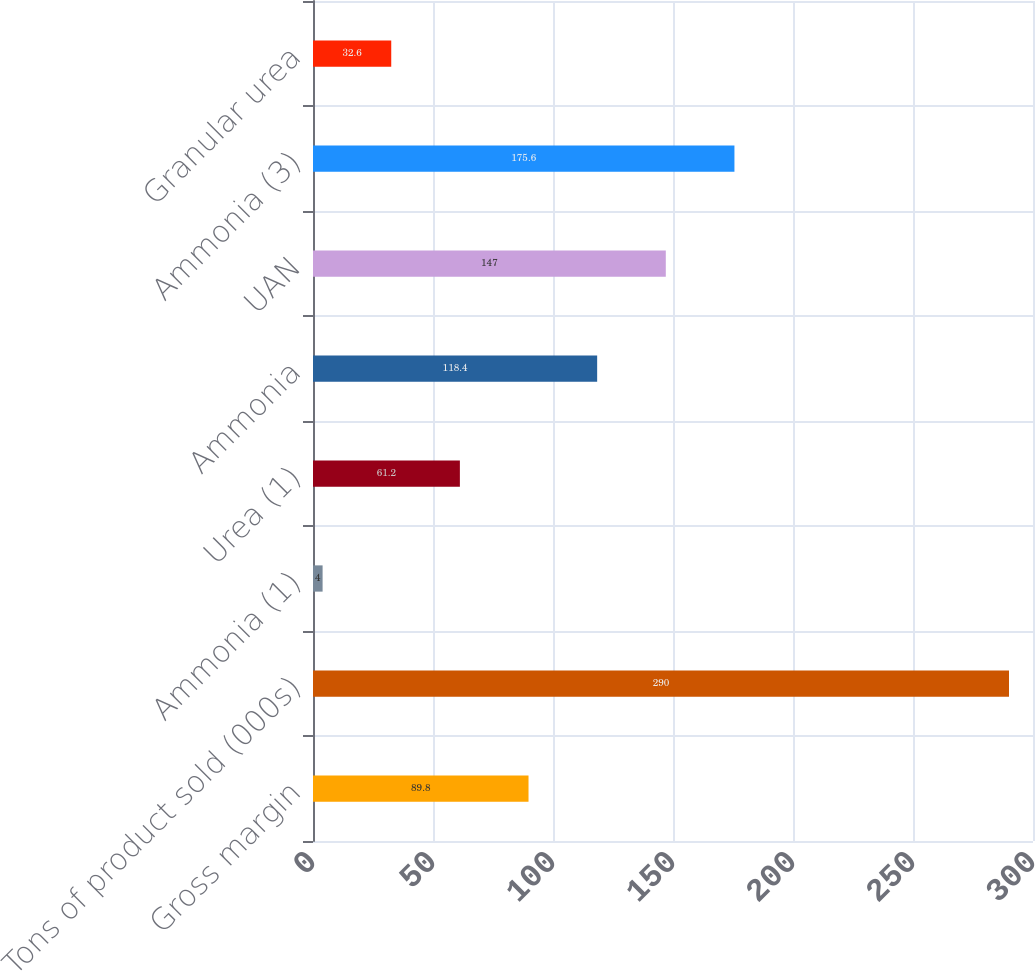<chart> <loc_0><loc_0><loc_500><loc_500><bar_chart><fcel>Gross margin<fcel>Tons of product sold (000s)<fcel>Ammonia (1)<fcel>Urea (1)<fcel>Ammonia<fcel>UAN<fcel>Ammonia (3)<fcel>Granular urea<nl><fcel>89.8<fcel>290<fcel>4<fcel>61.2<fcel>118.4<fcel>147<fcel>175.6<fcel>32.6<nl></chart> 